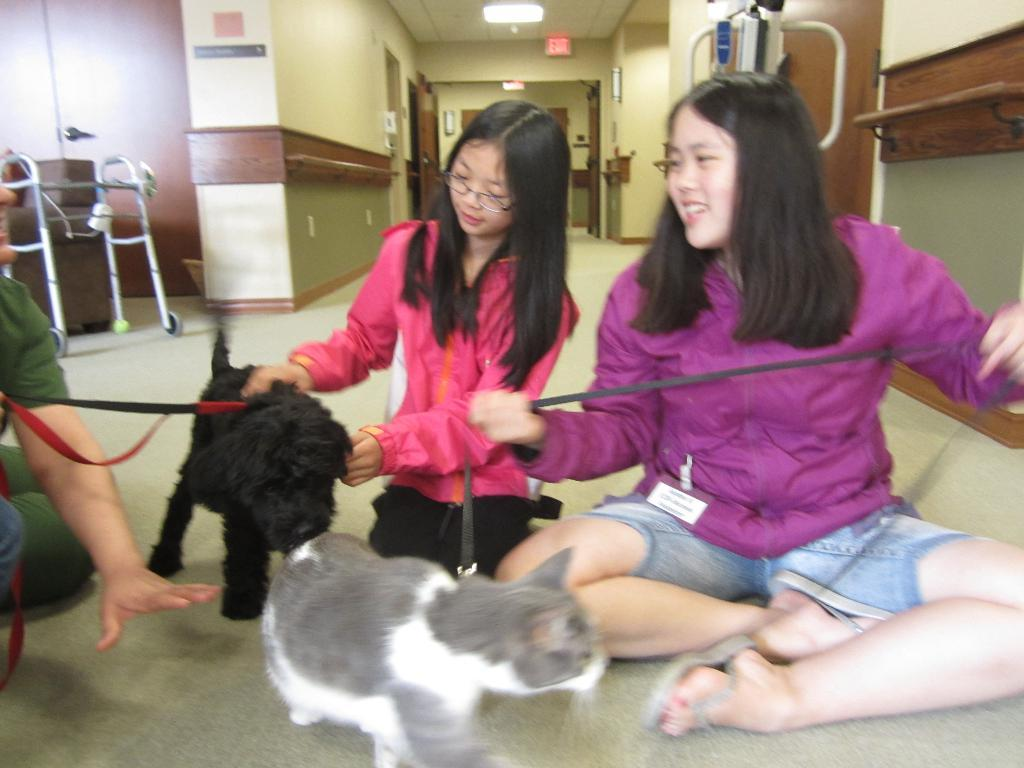What are the people in the image doing? The people in the image are sitting and holding belts in their hands. What can be seen walking on the floor in the image? There are animals walking on the floor in the image. What is visible in the background of the image? There is a wall, a light, and a couch in the background of the image. What type of hen can be seen reading a book in the image? There is no hen or book present in the image. Is there a carriage visible in the image? No, there is no carriage present in the image. 